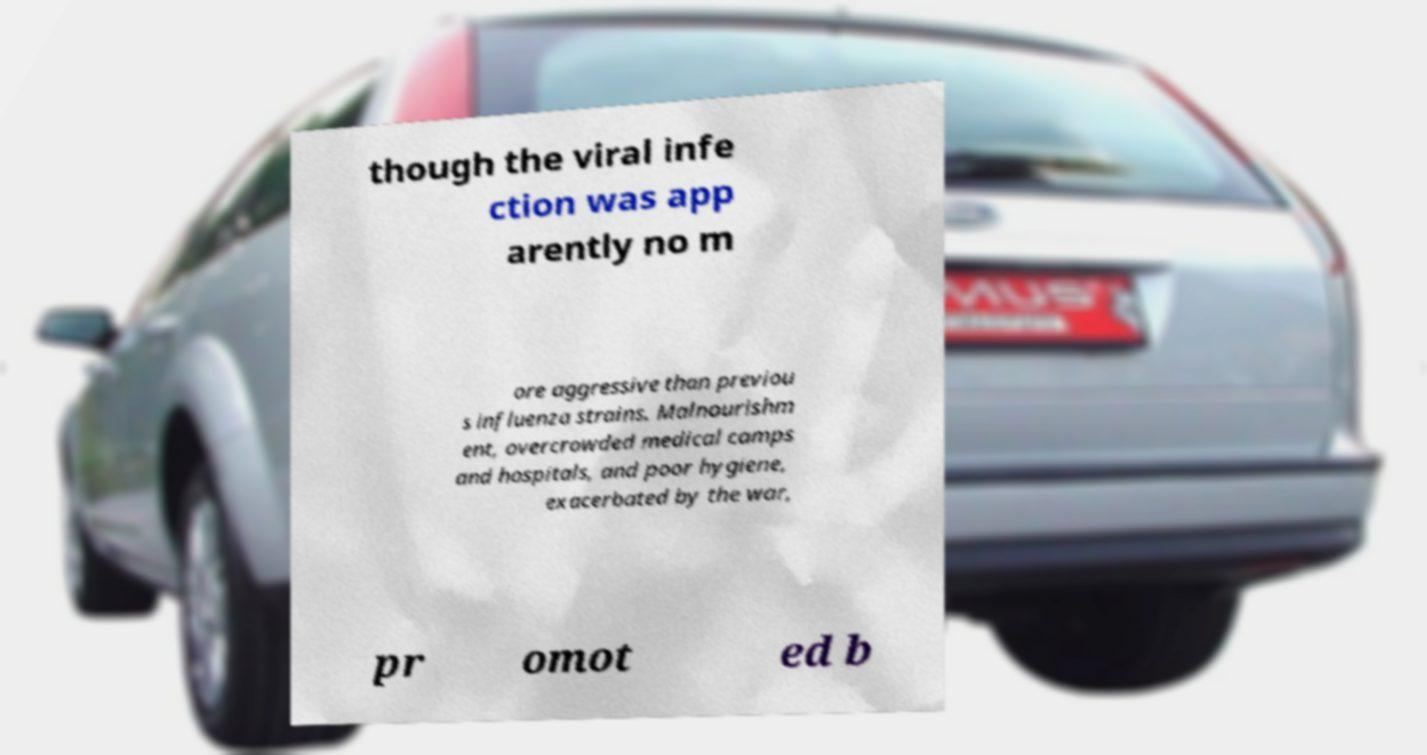Can you accurately transcribe the text from the provided image for me? though the viral infe ction was app arently no m ore aggressive than previou s influenza strains. Malnourishm ent, overcrowded medical camps and hospitals, and poor hygiene, exacerbated by the war, pr omot ed b 